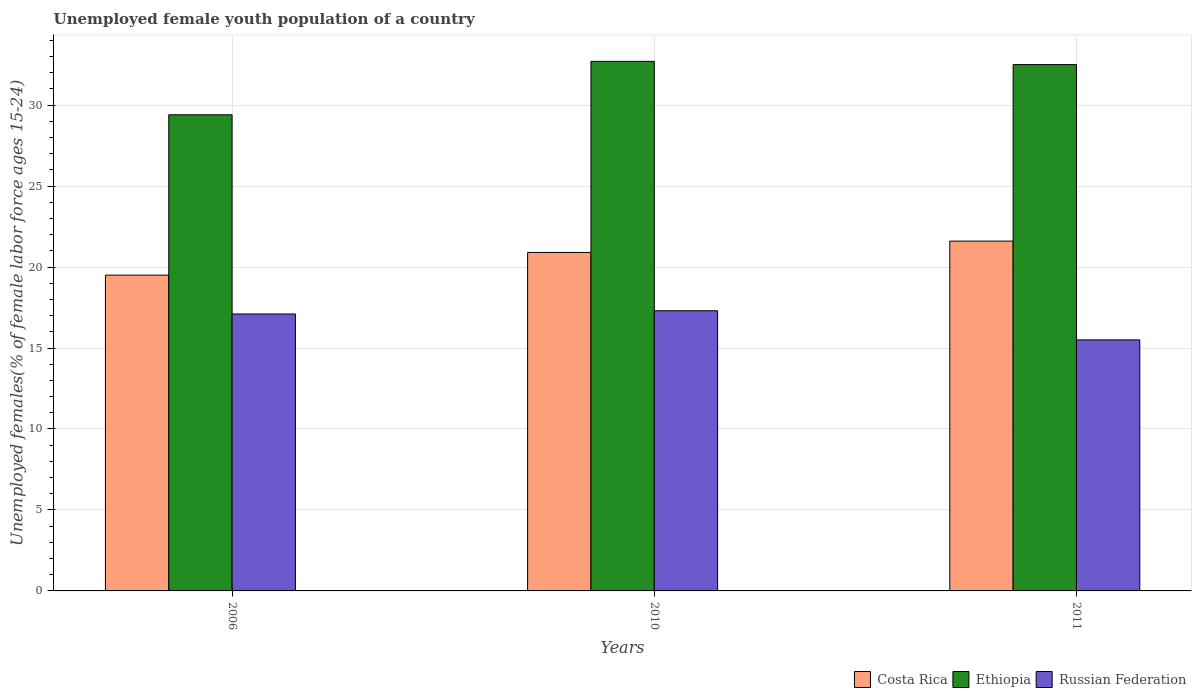How many groups of bars are there?
Offer a very short reply. 3. Are the number of bars per tick equal to the number of legend labels?
Give a very brief answer. Yes. How many bars are there on the 1st tick from the left?
Keep it short and to the point. 3. How many bars are there on the 3rd tick from the right?
Give a very brief answer. 3. What is the percentage of unemployed female youth population in Costa Rica in 2011?
Your response must be concise. 21.6. Across all years, what is the maximum percentage of unemployed female youth population in Ethiopia?
Your response must be concise. 32.7. Across all years, what is the minimum percentage of unemployed female youth population in Russian Federation?
Offer a very short reply. 15.5. What is the total percentage of unemployed female youth population in Ethiopia in the graph?
Your response must be concise. 94.6. What is the difference between the percentage of unemployed female youth population in Ethiopia in 2006 and that in 2011?
Provide a short and direct response. -3.1. What is the difference between the percentage of unemployed female youth population in Costa Rica in 2011 and the percentage of unemployed female youth population in Ethiopia in 2006?
Your answer should be very brief. -7.8. What is the average percentage of unemployed female youth population in Russian Federation per year?
Keep it short and to the point. 16.63. In the year 2006, what is the difference between the percentage of unemployed female youth population in Ethiopia and percentage of unemployed female youth population in Russian Federation?
Your response must be concise. 12.3. In how many years, is the percentage of unemployed female youth population in Russian Federation greater than 20 %?
Your answer should be very brief. 0. What is the ratio of the percentage of unemployed female youth population in Costa Rica in 2006 to that in 2010?
Keep it short and to the point. 0.93. Is the percentage of unemployed female youth population in Costa Rica in 2006 less than that in 2011?
Keep it short and to the point. Yes. What is the difference between the highest and the second highest percentage of unemployed female youth population in Costa Rica?
Your response must be concise. 0.7. What is the difference between the highest and the lowest percentage of unemployed female youth population in Costa Rica?
Your answer should be very brief. 2.1. In how many years, is the percentage of unemployed female youth population in Costa Rica greater than the average percentage of unemployed female youth population in Costa Rica taken over all years?
Provide a short and direct response. 2. Is the sum of the percentage of unemployed female youth population in Costa Rica in 2006 and 2011 greater than the maximum percentage of unemployed female youth population in Russian Federation across all years?
Keep it short and to the point. Yes. What does the 3rd bar from the left in 2010 represents?
Offer a terse response. Russian Federation. What does the 3rd bar from the right in 2010 represents?
Make the answer very short. Costa Rica. How many bars are there?
Offer a very short reply. 9. Are all the bars in the graph horizontal?
Provide a succinct answer. No. How many years are there in the graph?
Provide a short and direct response. 3. What is the difference between two consecutive major ticks on the Y-axis?
Keep it short and to the point. 5. Are the values on the major ticks of Y-axis written in scientific E-notation?
Provide a short and direct response. No. Does the graph contain any zero values?
Keep it short and to the point. No. Does the graph contain grids?
Your response must be concise. Yes. How many legend labels are there?
Provide a succinct answer. 3. What is the title of the graph?
Your answer should be compact. Unemployed female youth population of a country. What is the label or title of the Y-axis?
Provide a succinct answer. Unemployed females(% of female labor force ages 15-24). What is the Unemployed females(% of female labor force ages 15-24) in Costa Rica in 2006?
Your response must be concise. 19.5. What is the Unemployed females(% of female labor force ages 15-24) in Ethiopia in 2006?
Your answer should be very brief. 29.4. What is the Unemployed females(% of female labor force ages 15-24) in Russian Federation in 2006?
Your answer should be very brief. 17.1. What is the Unemployed females(% of female labor force ages 15-24) of Costa Rica in 2010?
Make the answer very short. 20.9. What is the Unemployed females(% of female labor force ages 15-24) in Ethiopia in 2010?
Provide a short and direct response. 32.7. What is the Unemployed females(% of female labor force ages 15-24) in Russian Federation in 2010?
Make the answer very short. 17.3. What is the Unemployed females(% of female labor force ages 15-24) in Costa Rica in 2011?
Make the answer very short. 21.6. What is the Unemployed females(% of female labor force ages 15-24) of Ethiopia in 2011?
Give a very brief answer. 32.5. Across all years, what is the maximum Unemployed females(% of female labor force ages 15-24) of Costa Rica?
Provide a succinct answer. 21.6. Across all years, what is the maximum Unemployed females(% of female labor force ages 15-24) of Ethiopia?
Provide a short and direct response. 32.7. Across all years, what is the maximum Unemployed females(% of female labor force ages 15-24) of Russian Federation?
Make the answer very short. 17.3. Across all years, what is the minimum Unemployed females(% of female labor force ages 15-24) in Costa Rica?
Your answer should be very brief. 19.5. Across all years, what is the minimum Unemployed females(% of female labor force ages 15-24) of Ethiopia?
Your answer should be compact. 29.4. Across all years, what is the minimum Unemployed females(% of female labor force ages 15-24) in Russian Federation?
Offer a terse response. 15.5. What is the total Unemployed females(% of female labor force ages 15-24) of Ethiopia in the graph?
Offer a terse response. 94.6. What is the total Unemployed females(% of female labor force ages 15-24) in Russian Federation in the graph?
Your answer should be compact. 49.9. What is the difference between the Unemployed females(% of female labor force ages 15-24) of Costa Rica in 2006 and that in 2010?
Offer a very short reply. -1.4. What is the difference between the Unemployed females(% of female labor force ages 15-24) of Ethiopia in 2006 and that in 2010?
Your answer should be very brief. -3.3. What is the difference between the Unemployed females(% of female labor force ages 15-24) of Costa Rica in 2006 and that in 2011?
Make the answer very short. -2.1. What is the difference between the Unemployed females(% of female labor force ages 15-24) of Costa Rica in 2010 and that in 2011?
Ensure brevity in your answer.  -0.7. What is the difference between the Unemployed females(% of female labor force ages 15-24) in Ethiopia in 2010 and that in 2011?
Ensure brevity in your answer.  0.2. What is the difference between the Unemployed females(% of female labor force ages 15-24) in Russian Federation in 2010 and that in 2011?
Your answer should be compact. 1.8. What is the difference between the Unemployed females(% of female labor force ages 15-24) in Costa Rica in 2006 and the Unemployed females(% of female labor force ages 15-24) in Ethiopia in 2011?
Offer a terse response. -13. What is the difference between the Unemployed females(% of female labor force ages 15-24) in Costa Rica in 2006 and the Unemployed females(% of female labor force ages 15-24) in Russian Federation in 2011?
Ensure brevity in your answer.  4. What is the difference between the Unemployed females(% of female labor force ages 15-24) of Ethiopia in 2006 and the Unemployed females(% of female labor force ages 15-24) of Russian Federation in 2011?
Give a very brief answer. 13.9. What is the difference between the Unemployed females(% of female labor force ages 15-24) of Costa Rica in 2010 and the Unemployed females(% of female labor force ages 15-24) of Ethiopia in 2011?
Your answer should be very brief. -11.6. What is the average Unemployed females(% of female labor force ages 15-24) of Costa Rica per year?
Your answer should be compact. 20.67. What is the average Unemployed females(% of female labor force ages 15-24) in Ethiopia per year?
Offer a terse response. 31.53. What is the average Unemployed females(% of female labor force ages 15-24) in Russian Federation per year?
Keep it short and to the point. 16.63. In the year 2006, what is the difference between the Unemployed females(% of female labor force ages 15-24) in Costa Rica and Unemployed females(% of female labor force ages 15-24) in Ethiopia?
Keep it short and to the point. -9.9. In the year 2006, what is the difference between the Unemployed females(% of female labor force ages 15-24) in Costa Rica and Unemployed females(% of female labor force ages 15-24) in Russian Federation?
Provide a succinct answer. 2.4. In the year 2006, what is the difference between the Unemployed females(% of female labor force ages 15-24) in Ethiopia and Unemployed females(% of female labor force ages 15-24) in Russian Federation?
Your answer should be compact. 12.3. In the year 2010, what is the difference between the Unemployed females(% of female labor force ages 15-24) in Costa Rica and Unemployed females(% of female labor force ages 15-24) in Ethiopia?
Offer a terse response. -11.8. In the year 2010, what is the difference between the Unemployed females(% of female labor force ages 15-24) of Ethiopia and Unemployed females(% of female labor force ages 15-24) of Russian Federation?
Your answer should be very brief. 15.4. In the year 2011, what is the difference between the Unemployed females(% of female labor force ages 15-24) of Costa Rica and Unemployed females(% of female labor force ages 15-24) of Russian Federation?
Ensure brevity in your answer.  6.1. In the year 2011, what is the difference between the Unemployed females(% of female labor force ages 15-24) of Ethiopia and Unemployed females(% of female labor force ages 15-24) of Russian Federation?
Keep it short and to the point. 17. What is the ratio of the Unemployed females(% of female labor force ages 15-24) in Costa Rica in 2006 to that in 2010?
Your answer should be very brief. 0.93. What is the ratio of the Unemployed females(% of female labor force ages 15-24) of Ethiopia in 2006 to that in 2010?
Ensure brevity in your answer.  0.9. What is the ratio of the Unemployed females(% of female labor force ages 15-24) in Russian Federation in 2006 to that in 2010?
Offer a terse response. 0.99. What is the ratio of the Unemployed females(% of female labor force ages 15-24) in Costa Rica in 2006 to that in 2011?
Provide a succinct answer. 0.9. What is the ratio of the Unemployed females(% of female labor force ages 15-24) of Ethiopia in 2006 to that in 2011?
Provide a succinct answer. 0.9. What is the ratio of the Unemployed females(% of female labor force ages 15-24) of Russian Federation in 2006 to that in 2011?
Provide a short and direct response. 1.1. What is the ratio of the Unemployed females(% of female labor force ages 15-24) of Costa Rica in 2010 to that in 2011?
Keep it short and to the point. 0.97. What is the ratio of the Unemployed females(% of female labor force ages 15-24) of Russian Federation in 2010 to that in 2011?
Ensure brevity in your answer.  1.12. What is the difference between the highest and the second highest Unemployed females(% of female labor force ages 15-24) in Costa Rica?
Your response must be concise. 0.7. What is the difference between the highest and the second highest Unemployed females(% of female labor force ages 15-24) in Ethiopia?
Offer a terse response. 0.2. What is the difference between the highest and the lowest Unemployed females(% of female labor force ages 15-24) of Costa Rica?
Your answer should be very brief. 2.1. What is the difference between the highest and the lowest Unemployed females(% of female labor force ages 15-24) in Ethiopia?
Keep it short and to the point. 3.3. 